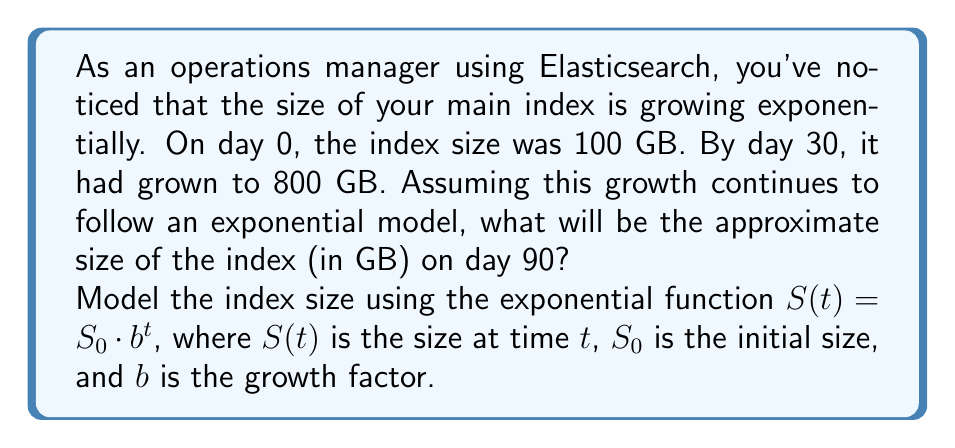Show me your answer to this math problem. To solve this problem, we'll use the exponential growth model $S(t) = S_0 \cdot b^t$, where:
$S(t)$ = size at time $t$
$S_0$ = initial size (100 GB)
$b$ = growth factor (to be determined)
$t$ = time in days

1. We know two points: 
   At $t = 0$: $S(0) = 100$ GB
   At $t = 30$: $S(30) = 800$ GB

2. Let's use the second point to find $b$:
   $$800 = 100 \cdot b^{30}$$

3. Divide both sides by 100:
   $$8 = b^{30}$$

4. Take the 30th root of both sides:
   $$b = \sqrt[30]{8} \approx 1.0718$$

5. Now we have our complete model:
   $$S(t) = 100 \cdot 1.0718^t$$

6. To find the size at day 90, we plug in $t = 90$:
   $$S(90) = 100 \cdot 1.0718^{90}$$

7. Calculate:
   $$S(90) \approx 100 \cdot 585.37 \approx 58,537$$ GB
Answer: The approximate size of the Elasticsearch index on day 90 will be 58,537 GB or about 58.5 TB. 